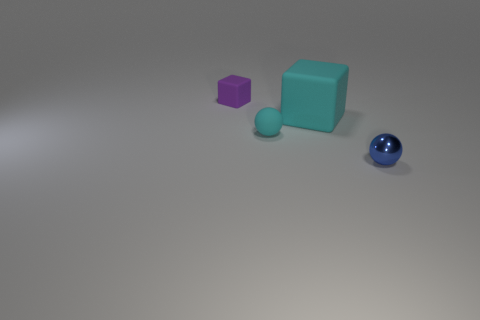Subtract all yellow blocks. Subtract all gray cylinders. How many blocks are left? 2 Add 4 small red rubber objects. How many objects exist? 8 Subtract all big brown cylinders. Subtract all purple rubber objects. How many objects are left? 3 Add 4 small blue metal objects. How many small blue metal objects are left? 5 Add 4 metal spheres. How many metal spheres exist? 5 Subtract 0 red cubes. How many objects are left? 4 